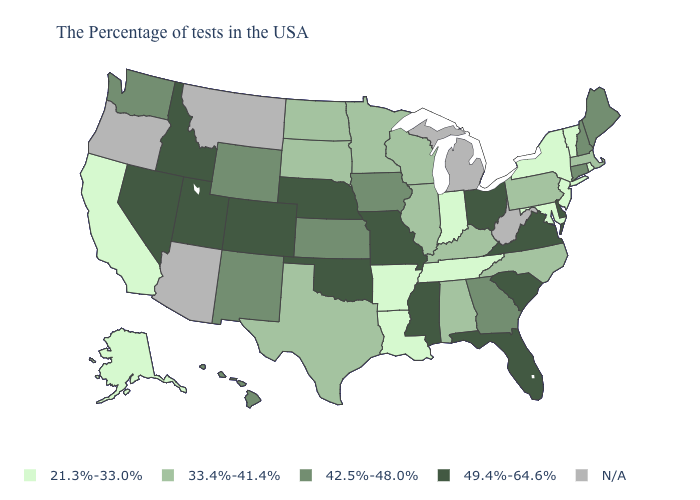What is the value of Alabama?
Be succinct. 33.4%-41.4%. Does the first symbol in the legend represent the smallest category?
Give a very brief answer. Yes. Name the states that have a value in the range 21.3%-33.0%?
Keep it brief. Rhode Island, Vermont, New York, New Jersey, Maryland, Indiana, Tennessee, Louisiana, Arkansas, California, Alaska. Does the first symbol in the legend represent the smallest category?
Quick response, please. Yes. Name the states that have a value in the range 49.4%-64.6%?
Answer briefly. Delaware, Virginia, South Carolina, Ohio, Florida, Mississippi, Missouri, Nebraska, Oklahoma, Colorado, Utah, Idaho, Nevada. Name the states that have a value in the range 21.3%-33.0%?
Concise answer only. Rhode Island, Vermont, New York, New Jersey, Maryland, Indiana, Tennessee, Louisiana, Arkansas, California, Alaska. Which states have the lowest value in the USA?
Short answer required. Rhode Island, Vermont, New York, New Jersey, Maryland, Indiana, Tennessee, Louisiana, Arkansas, California, Alaska. What is the value of Missouri?
Write a very short answer. 49.4%-64.6%. Among the states that border Delaware , which have the highest value?
Answer briefly. Pennsylvania. Does the first symbol in the legend represent the smallest category?
Keep it brief. Yes. What is the value of Georgia?
Be succinct. 42.5%-48.0%. What is the value of Louisiana?
Write a very short answer. 21.3%-33.0%. What is the value of New Jersey?
Answer briefly. 21.3%-33.0%. What is the lowest value in the USA?
Keep it brief. 21.3%-33.0%. 